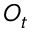Convert formula to latex. <formula><loc_0><loc_0><loc_500><loc_500>O _ { t }</formula> 